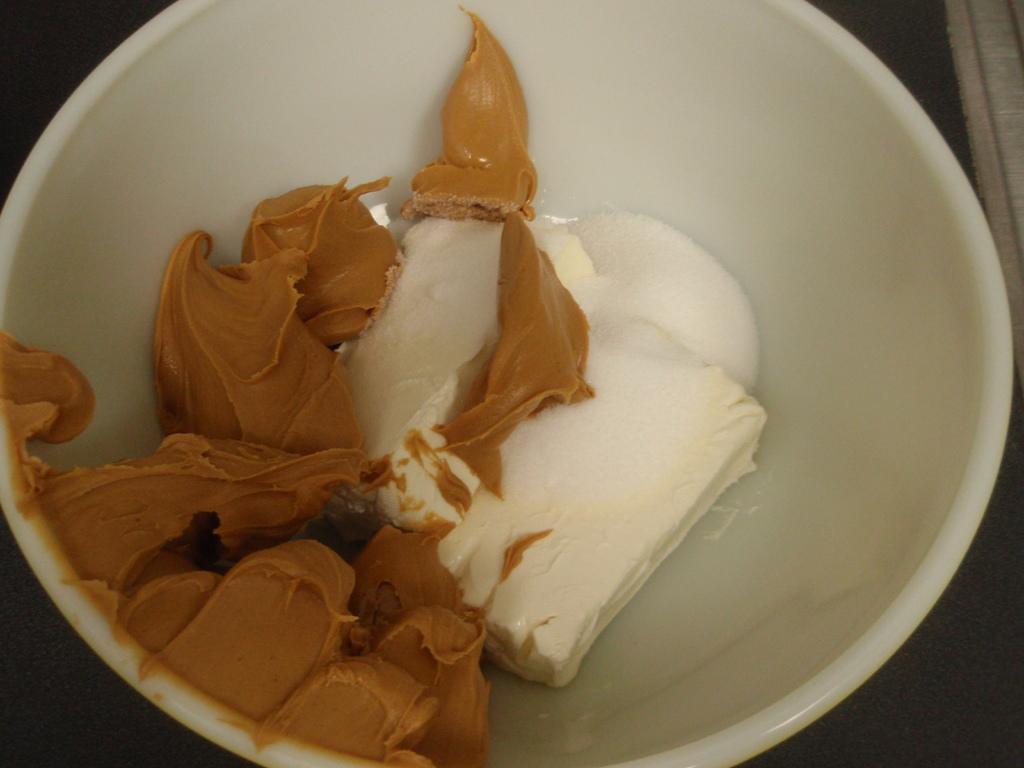In one or two sentences, can you explain what this image depicts? This is the picture of a bowl in which there is some chocolate and some other cream in it. 